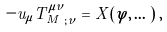Convert formula to latex. <formula><loc_0><loc_0><loc_500><loc_500>- u _ { \mu } { T ^ { \mu \nu } _ { M } } _ { ; \nu } = X ( \varphi , \dots ) \, ,</formula> 